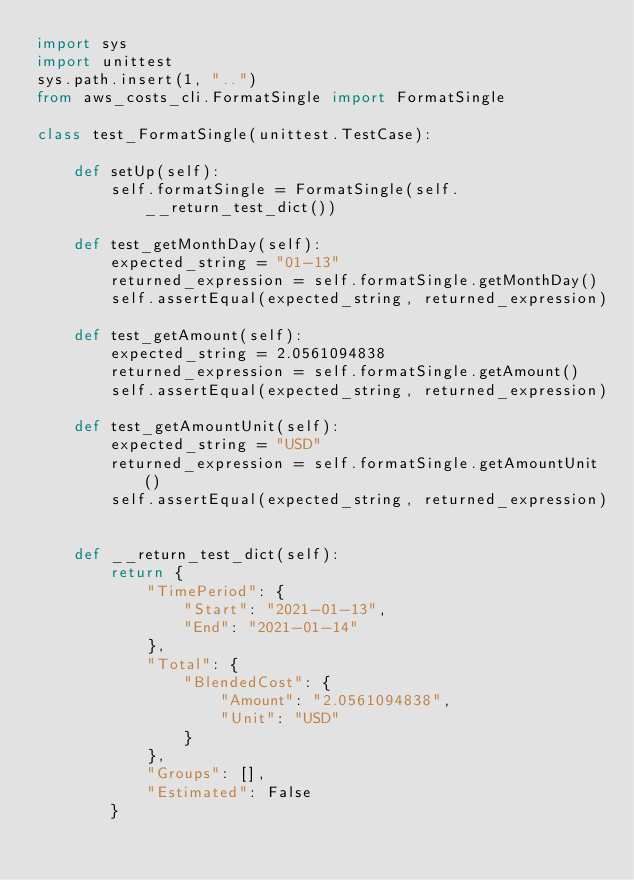Convert code to text. <code><loc_0><loc_0><loc_500><loc_500><_Python_>import sys
import unittest
sys.path.insert(1, "..")
from aws_costs_cli.FormatSingle import FormatSingle

class test_FormatSingle(unittest.TestCase):

    def setUp(self):
        self.formatSingle = FormatSingle(self.__return_test_dict())

    def test_getMonthDay(self):
        expected_string = "01-13"
        returned_expression = self.formatSingle.getMonthDay()
        self.assertEqual(expected_string, returned_expression)

    def test_getAmount(self):
        expected_string = 2.0561094838
        returned_expression = self.formatSingle.getAmount()
        self.assertEqual(expected_string, returned_expression)

    def test_getAmountUnit(self):
        expected_string = "USD"
        returned_expression = self.formatSingle.getAmountUnit()
        self.assertEqual(expected_string, returned_expression)


    def __return_test_dict(self):
        return {
            "TimePeriod": {
                "Start": "2021-01-13",
                "End": "2021-01-14"
            },
            "Total": {
                "BlendedCost": {
                    "Amount": "2.0561094838",
                    "Unit": "USD"
                }
            },
            "Groups": [],
            "Estimated": False
        }

</code> 